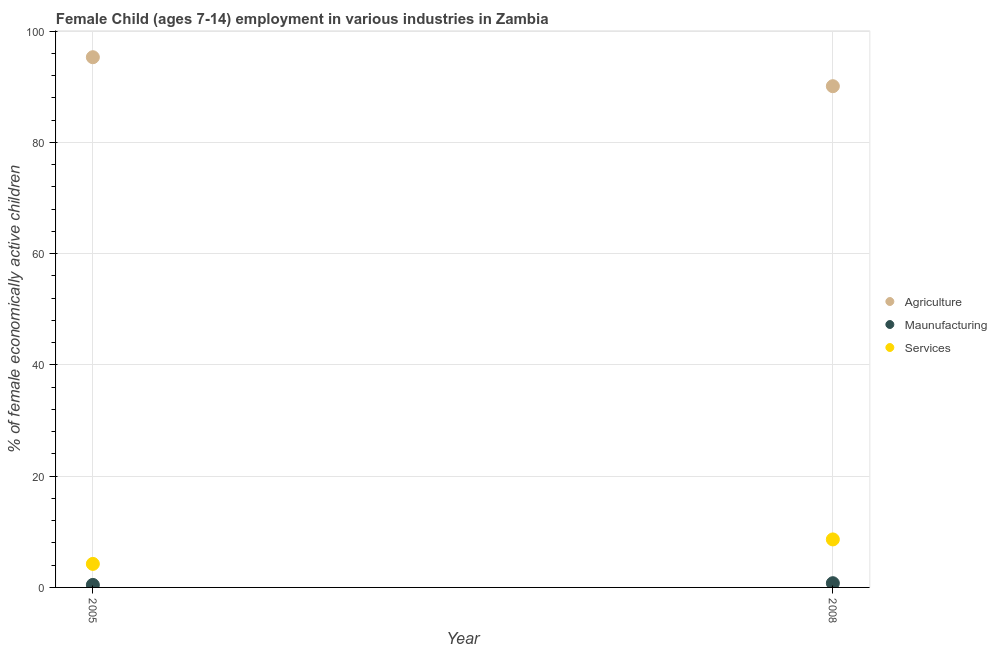Is the number of dotlines equal to the number of legend labels?
Your answer should be very brief. Yes. What is the percentage of economically active children in services in 2008?
Make the answer very short. 8.63. Across all years, what is the maximum percentage of economically active children in services?
Keep it short and to the point. 8.63. Across all years, what is the minimum percentage of economically active children in agriculture?
Provide a succinct answer. 90.11. What is the total percentage of economically active children in agriculture in the graph?
Ensure brevity in your answer.  185.43. What is the difference between the percentage of economically active children in manufacturing in 2005 and that in 2008?
Your answer should be compact. -0.31. What is the difference between the percentage of economically active children in services in 2005 and the percentage of economically active children in manufacturing in 2008?
Your response must be concise. 3.47. What is the average percentage of economically active children in agriculture per year?
Keep it short and to the point. 92.72. In the year 2005, what is the difference between the percentage of economically active children in services and percentage of economically active children in manufacturing?
Offer a very short reply. 3.78. In how many years, is the percentage of economically active children in manufacturing greater than 4 %?
Make the answer very short. 0. What is the ratio of the percentage of economically active children in services in 2005 to that in 2008?
Keep it short and to the point. 0.49. Is the percentage of economically active children in manufacturing in 2005 less than that in 2008?
Offer a terse response. Yes. Is it the case that in every year, the sum of the percentage of economically active children in agriculture and percentage of economically active children in manufacturing is greater than the percentage of economically active children in services?
Keep it short and to the point. Yes. Does the percentage of economically active children in manufacturing monotonically increase over the years?
Ensure brevity in your answer.  Yes. Is the percentage of economically active children in agriculture strictly less than the percentage of economically active children in manufacturing over the years?
Provide a short and direct response. No. What is the difference between two consecutive major ticks on the Y-axis?
Ensure brevity in your answer.  20. Where does the legend appear in the graph?
Make the answer very short. Center right. How many legend labels are there?
Your answer should be very brief. 3. What is the title of the graph?
Your response must be concise. Female Child (ages 7-14) employment in various industries in Zambia. Does "Fuel" appear as one of the legend labels in the graph?
Make the answer very short. No. What is the label or title of the X-axis?
Offer a very short reply. Year. What is the label or title of the Y-axis?
Give a very brief answer. % of female economically active children. What is the % of female economically active children of Agriculture in 2005?
Offer a very short reply. 95.32. What is the % of female economically active children of Maunufacturing in 2005?
Make the answer very short. 0.45. What is the % of female economically active children of Services in 2005?
Provide a succinct answer. 4.23. What is the % of female economically active children in Agriculture in 2008?
Offer a very short reply. 90.11. What is the % of female economically active children of Maunufacturing in 2008?
Make the answer very short. 0.76. What is the % of female economically active children of Services in 2008?
Keep it short and to the point. 8.63. Across all years, what is the maximum % of female economically active children of Agriculture?
Provide a short and direct response. 95.32. Across all years, what is the maximum % of female economically active children in Maunufacturing?
Keep it short and to the point. 0.76. Across all years, what is the maximum % of female economically active children in Services?
Your answer should be very brief. 8.63. Across all years, what is the minimum % of female economically active children of Agriculture?
Provide a succinct answer. 90.11. Across all years, what is the minimum % of female economically active children in Maunufacturing?
Your answer should be very brief. 0.45. Across all years, what is the minimum % of female economically active children of Services?
Give a very brief answer. 4.23. What is the total % of female economically active children in Agriculture in the graph?
Ensure brevity in your answer.  185.43. What is the total % of female economically active children in Maunufacturing in the graph?
Your answer should be very brief. 1.21. What is the total % of female economically active children of Services in the graph?
Keep it short and to the point. 12.86. What is the difference between the % of female economically active children of Agriculture in 2005 and that in 2008?
Ensure brevity in your answer.  5.21. What is the difference between the % of female economically active children of Maunufacturing in 2005 and that in 2008?
Your answer should be compact. -0.31. What is the difference between the % of female economically active children of Services in 2005 and that in 2008?
Your response must be concise. -4.4. What is the difference between the % of female economically active children of Agriculture in 2005 and the % of female economically active children of Maunufacturing in 2008?
Provide a short and direct response. 94.56. What is the difference between the % of female economically active children in Agriculture in 2005 and the % of female economically active children in Services in 2008?
Offer a very short reply. 86.69. What is the difference between the % of female economically active children in Maunufacturing in 2005 and the % of female economically active children in Services in 2008?
Give a very brief answer. -8.18. What is the average % of female economically active children of Agriculture per year?
Your answer should be very brief. 92.72. What is the average % of female economically active children in Maunufacturing per year?
Offer a terse response. 0.6. What is the average % of female economically active children in Services per year?
Offer a very short reply. 6.43. In the year 2005, what is the difference between the % of female economically active children in Agriculture and % of female economically active children in Maunufacturing?
Your response must be concise. 94.87. In the year 2005, what is the difference between the % of female economically active children of Agriculture and % of female economically active children of Services?
Your response must be concise. 91.09. In the year 2005, what is the difference between the % of female economically active children of Maunufacturing and % of female economically active children of Services?
Keep it short and to the point. -3.78. In the year 2008, what is the difference between the % of female economically active children in Agriculture and % of female economically active children in Maunufacturing?
Provide a succinct answer. 89.35. In the year 2008, what is the difference between the % of female economically active children of Agriculture and % of female economically active children of Services?
Ensure brevity in your answer.  81.48. In the year 2008, what is the difference between the % of female economically active children in Maunufacturing and % of female economically active children in Services?
Offer a terse response. -7.87. What is the ratio of the % of female economically active children in Agriculture in 2005 to that in 2008?
Your answer should be very brief. 1.06. What is the ratio of the % of female economically active children in Maunufacturing in 2005 to that in 2008?
Your response must be concise. 0.59. What is the ratio of the % of female economically active children of Services in 2005 to that in 2008?
Offer a terse response. 0.49. What is the difference between the highest and the second highest % of female economically active children of Agriculture?
Offer a very short reply. 5.21. What is the difference between the highest and the second highest % of female economically active children in Maunufacturing?
Your response must be concise. 0.31. What is the difference between the highest and the lowest % of female economically active children in Agriculture?
Provide a succinct answer. 5.21. What is the difference between the highest and the lowest % of female economically active children of Maunufacturing?
Provide a succinct answer. 0.31. What is the difference between the highest and the lowest % of female economically active children of Services?
Your answer should be very brief. 4.4. 